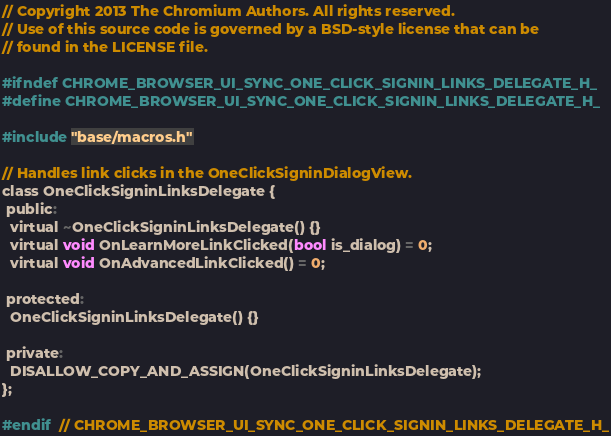Convert code to text. <code><loc_0><loc_0><loc_500><loc_500><_C_>// Copyright 2013 The Chromium Authors. All rights reserved.
// Use of this source code is governed by a BSD-style license that can be
// found in the LICENSE file.

#ifndef CHROME_BROWSER_UI_SYNC_ONE_CLICK_SIGNIN_LINKS_DELEGATE_H_
#define CHROME_BROWSER_UI_SYNC_ONE_CLICK_SIGNIN_LINKS_DELEGATE_H_

#include "base/macros.h"

// Handles link clicks in the OneClickSigninDialogView.
class OneClickSigninLinksDelegate {
 public:
  virtual ~OneClickSigninLinksDelegate() {}
  virtual void OnLearnMoreLinkClicked(bool is_dialog) = 0;
  virtual void OnAdvancedLinkClicked() = 0;

 protected:
  OneClickSigninLinksDelegate() {}

 private:
  DISALLOW_COPY_AND_ASSIGN(OneClickSigninLinksDelegate);
};

#endif  // CHROME_BROWSER_UI_SYNC_ONE_CLICK_SIGNIN_LINKS_DELEGATE_H_
</code> 